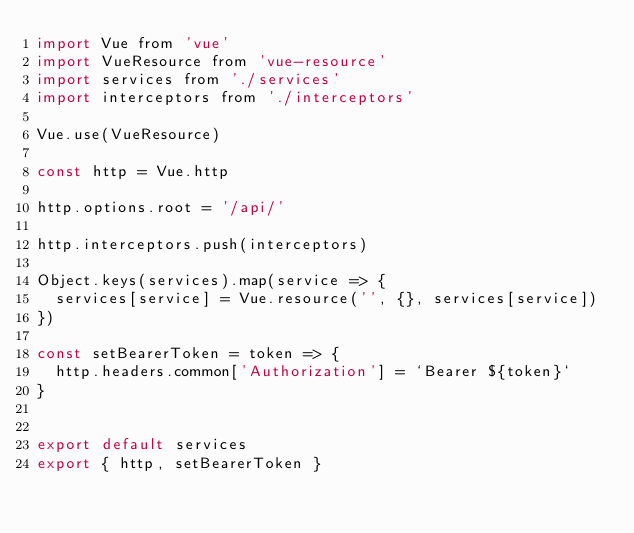Convert code to text. <code><loc_0><loc_0><loc_500><loc_500><_JavaScript_>import Vue from 'vue'
import VueResource from 'vue-resource'
import services from './services'
import interceptors from './interceptors'

Vue.use(VueResource)

const http = Vue.http

http.options.root = '/api/'

http.interceptors.push(interceptors)

Object.keys(services).map(service => {
  services[service] = Vue.resource('', {}, services[service])
})

const setBearerToken = token => {
  http.headers.common['Authorization'] = `Bearer ${token}`
}


export default services
export { http, setBearerToken }
</code> 